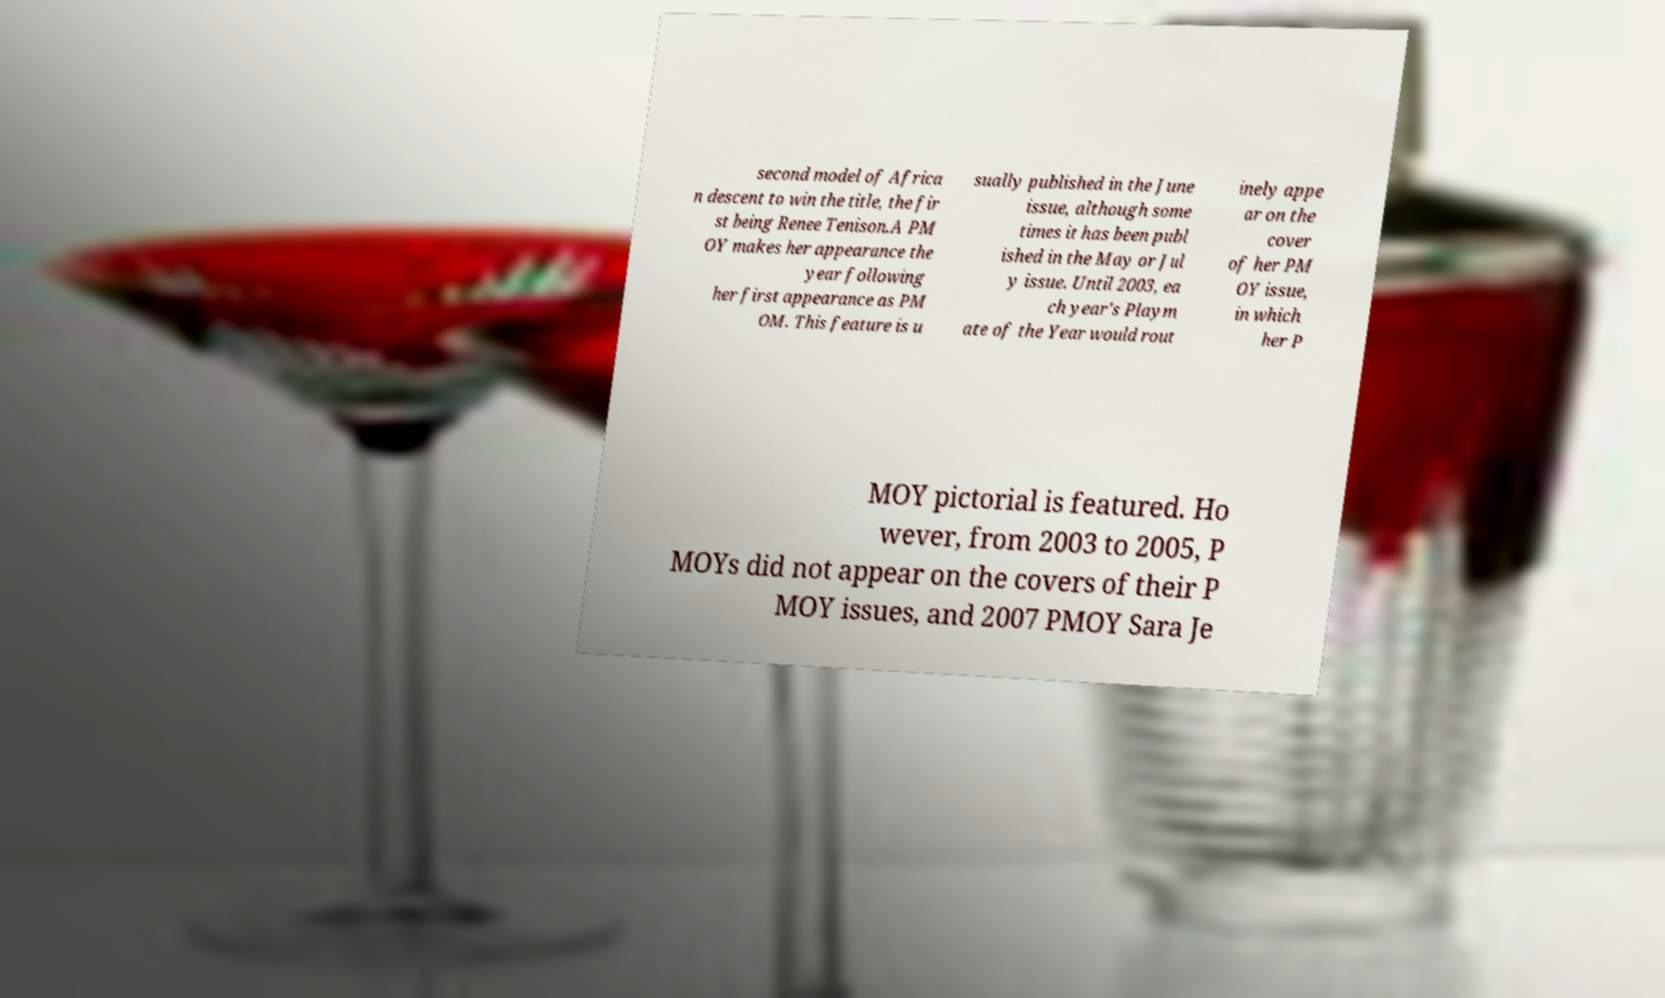There's text embedded in this image that I need extracted. Can you transcribe it verbatim? second model of Africa n descent to win the title, the fir st being Renee Tenison.A PM OY makes her appearance the year following her first appearance as PM OM. This feature is u sually published in the June issue, although some times it has been publ ished in the May or Jul y issue. Until 2003, ea ch year's Playm ate of the Year would rout inely appe ar on the cover of her PM OY issue, in which her P MOY pictorial is featured. Ho wever, from 2003 to 2005, P MOYs did not appear on the covers of their P MOY issues, and 2007 PMOY Sara Je 